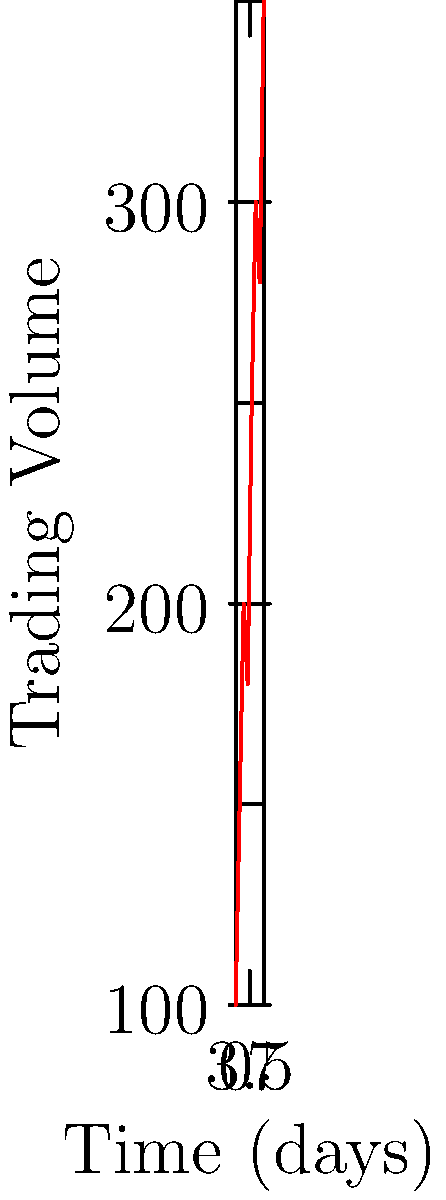As a technology journalist investigating automated trading systems, you're analyzing the trading volume of a particular cryptocurrency over a week. The line graph shows the daily trading volume from Monday to the following Monday. What is the percentage increase in trading volume from the first Monday to the second Monday? To calculate the percentage increase in trading volume from the first Monday to the second Monday, we'll follow these steps:

1. Identify the trading volume on the first Monday (day 0): 100 units
2. Identify the trading volume on the second Monday (day 7): 350 units
3. Calculate the absolute increase: 350 - 100 = 250 units
4. Calculate the percentage increase using the formula:
   Percentage increase = (Increase / Original Value) × 100
   
   $$ \text{Percentage increase} = \frac{350 - 100}{100} \times 100 = \frac{250}{100} \times 100 = 250\% $$

Therefore, the trading volume increased by 250% from the first Monday to the second Monday.
Answer: 250% 